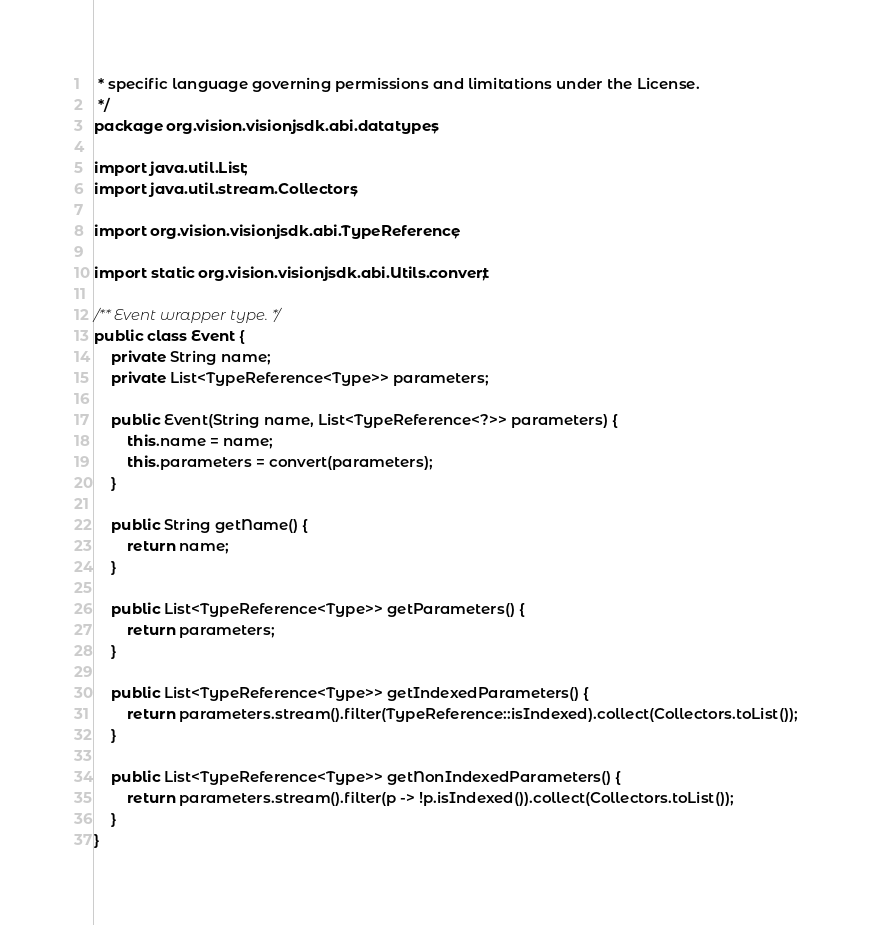Convert code to text. <code><loc_0><loc_0><loc_500><loc_500><_Java_> * specific language governing permissions and limitations under the License.
 */
package org.vision.visionjsdk.abi.datatypes;

import java.util.List;
import java.util.stream.Collectors;

import org.vision.visionjsdk.abi.TypeReference;

import static org.vision.visionjsdk.abi.Utils.convert;

/** Event wrapper type. */
public class Event {
    private String name;
    private List<TypeReference<Type>> parameters;

    public Event(String name, List<TypeReference<?>> parameters) {
        this.name = name;
        this.parameters = convert(parameters);
    }

    public String getName() {
        return name;
    }

    public List<TypeReference<Type>> getParameters() {
        return parameters;
    }

    public List<TypeReference<Type>> getIndexedParameters() {
        return parameters.stream().filter(TypeReference::isIndexed).collect(Collectors.toList());
    }

    public List<TypeReference<Type>> getNonIndexedParameters() {
        return parameters.stream().filter(p -> !p.isIndexed()).collect(Collectors.toList());
    }
}
</code> 